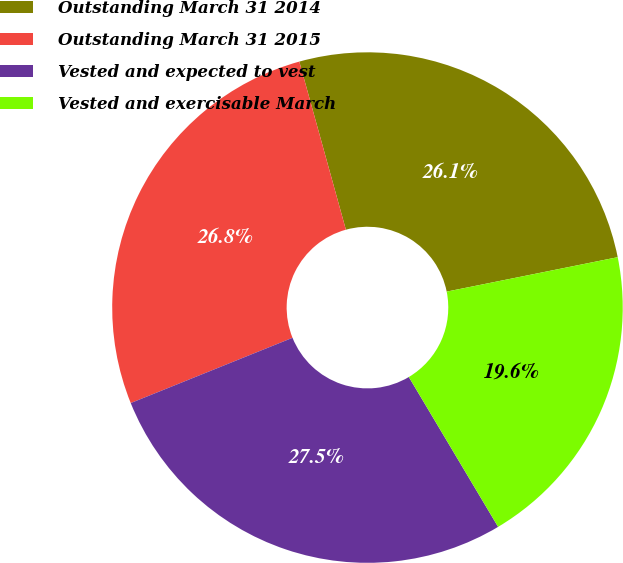Convert chart to OTSL. <chart><loc_0><loc_0><loc_500><loc_500><pie_chart><fcel>Outstanding March 31 2014<fcel>Outstanding March 31 2015<fcel>Vested and expected to vest<fcel>Vested and exercisable March<nl><fcel>26.14%<fcel>26.8%<fcel>27.45%<fcel>19.61%<nl></chart> 